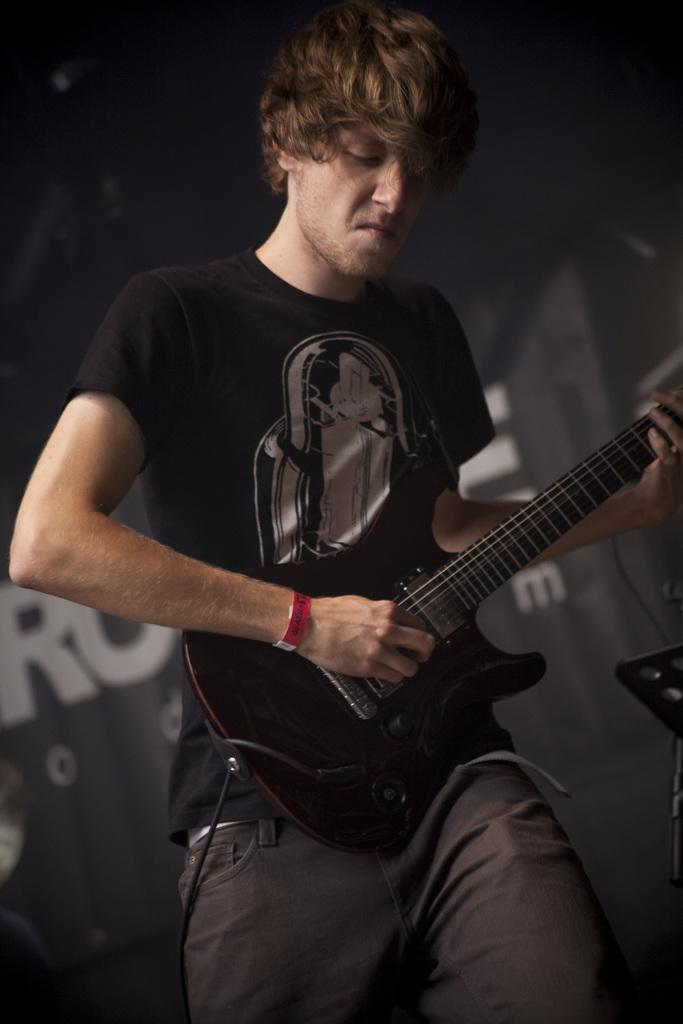What is the person in the image doing? The person is playing a guitar. Can you describe the person's activity in more detail? The person is standing while playing the guitar. What can be seen in the background of the image? There is a banner in the background of the image. How does the person's muscle strength contribute to their ability to play the guitar in the image? The image does not provide information about the person's muscle strength, so it cannot be determined how it contributes to their ability to play the guitar. 